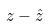<formula> <loc_0><loc_0><loc_500><loc_500>z - \hat { z }</formula> 